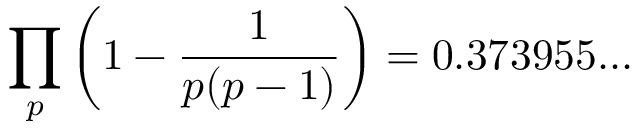Convert formula to latex. <formula><loc_0><loc_0><loc_500><loc_500>\prod _ { p } \left ( 1 - { \frac { 1 } { p ( p - 1 ) } } \right ) = 0 . 3 7 3 9 5 5 \dots</formula> 